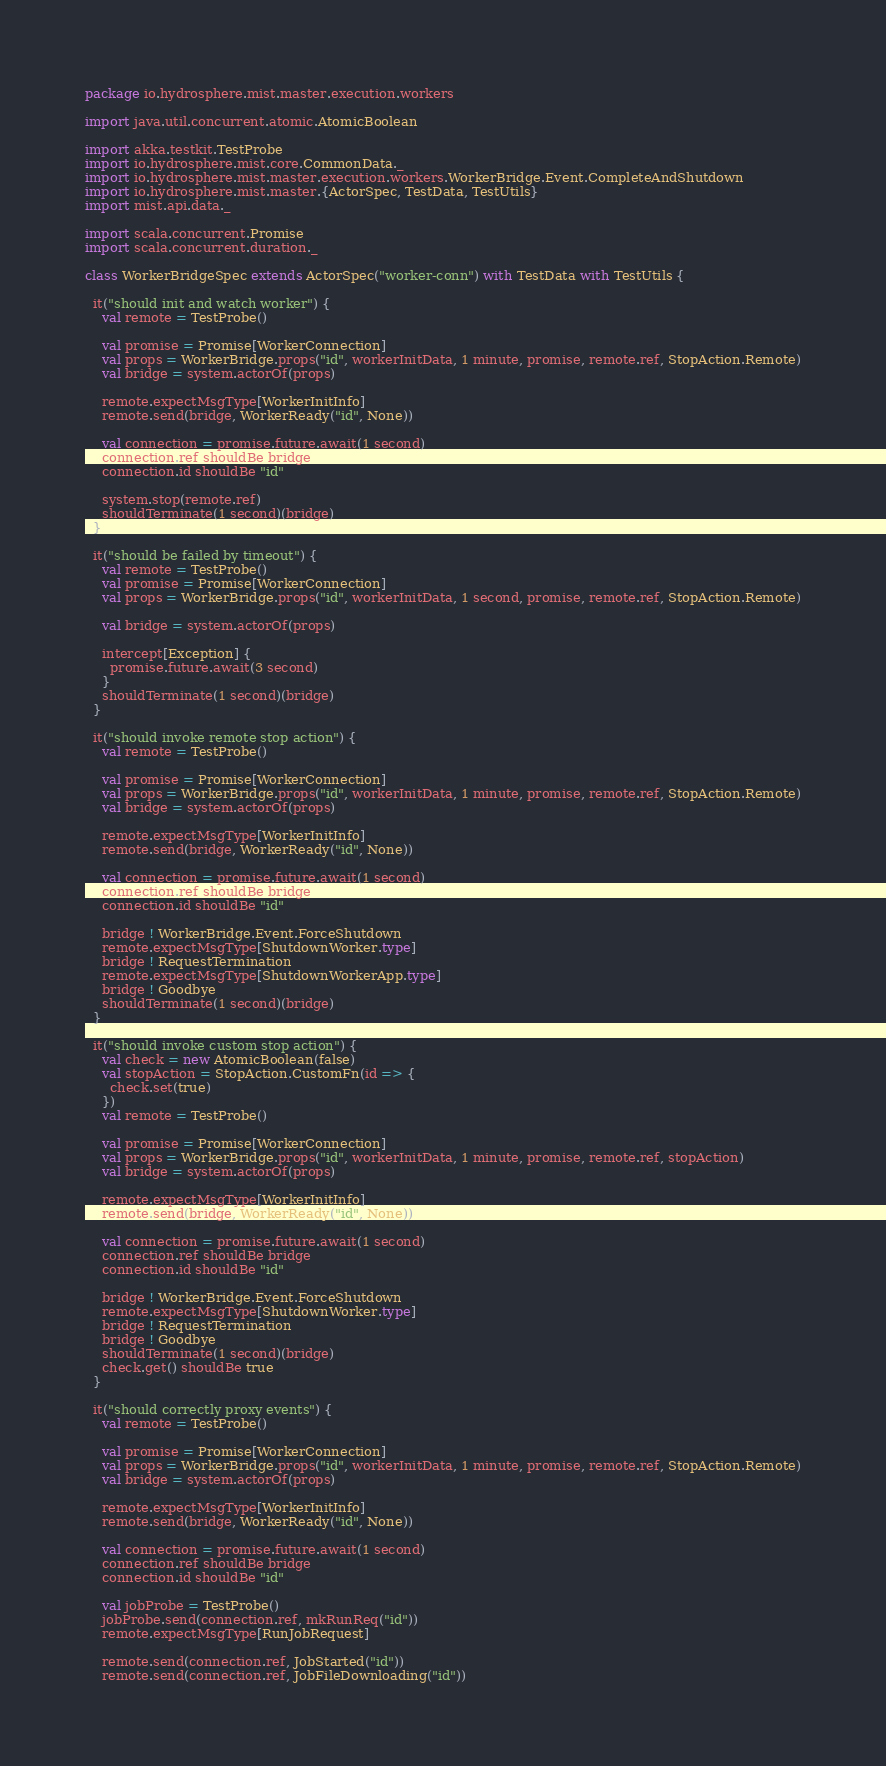<code> <loc_0><loc_0><loc_500><loc_500><_Scala_>package io.hydrosphere.mist.master.execution.workers

import java.util.concurrent.atomic.AtomicBoolean

import akka.testkit.TestProbe
import io.hydrosphere.mist.core.CommonData._
import io.hydrosphere.mist.master.execution.workers.WorkerBridge.Event.CompleteAndShutdown
import io.hydrosphere.mist.master.{ActorSpec, TestData, TestUtils}
import mist.api.data._

import scala.concurrent.Promise
import scala.concurrent.duration._

class WorkerBridgeSpec extends ActorSpec("worker-conn") with TestData with TestUtils {

  it("should init and watch worker") {
    val remote = TestProbe()

    val promise = Promise[WorkerConnection]
    val props = WorkerBridge.props("id", workerInitData, 1 minute, promise, remote.ref, StopAction.Remote)
    val bridge = system.actorOf(props)

    remote.expectMsgType[WorkerInitInfo]
    remote.send(bridge, WorkerReady("id", None))

    val connection = promise.future.await(1 second)
    connection.ref shouldBe bridge
    connection.id shouldBe "id"

    system.stop(remote.ref)
    shouldTerminate(1 second)(bridge)
  }

  it("should be failed by timeout") {
    val remote = TestProbe()
    val promise = Promise[WorkerConnection]
    val props = WorkerBridge.props("id", workerInitData, 1 second, promise, remote.ref, StopAction.Remote)

    val bridge = system.actorOf(props)

    intercept[Exception] {
      promise.future.await(3 second)
    }
    shouldTerminate(1 second)(bridge)
  }

  it("should invoke remote stop action") {
    val remote = TestProbe()

    val promise = Promise[WorkerConnection]
    val props = WorkerBridge.props("id", workerInitData, 1 minute, promise, remote.ref, StopAction.Remote)
    val bridge = system.actorOf(props)

    remote.expectMsgType[WorkerInitInfo]
    remote.send(bridge, WorkerReady("id", None))

    val connection = promise.future.await(1 second)
    connection.ref shouldBe bridge
    connection.id shouldBe "id"

    bridge ! WorkerBridge.Event.ForceShutdown
    remote.expectMsgType[ShutdownWorker.type]
    bridge ! RequestTermination
    remote.expectMsgType[ShutdownWorkerApp.type]
    bridge ! Goodbye
    shouldTerminate(1 second)(bridge)
  }

  it("should invoke custom stop action") {
    val check = new AtomicBoolean(false)
    val stopAction = StopAction.CustomFn(id => {
      check.set(true)
    })
    val remote = TestProbe()

    val promise = Promise[WorkerConnection]
    val props = WorkerBridge.props("id", workerInitData, 1 minute, promise, remote.ref, stopAction)
    val bridge = system.actorOf(props)

    remote.expectMsgType[WorkerInitInfo]
    remote.send(bridge, WorkerReady("id", None))

    val connection = promise.future.await(1 second)
    connection.ref shouldBe bridge
    connection.id shouldBe "id"

    bridge ! WorkerBridge.Event.ForceShutdown
    remote.expectMsgType[ShutdownWorker.type]
    bridge ! RequestTermination
    bridge ! Goodbye
    shouldTerminate(1 second)(bridge)
    check.get() shouldBe true
  }

  it("should correctly proxy events") {
    val remote = TestProbe()

    val promise = Promise[WorkerConnection]
    val props = WorkerBridge.props("id", workerInitData, 1 minute, promise, remote.ref, StopAction.Remote)
    val bridge = system.actorOf(props)

    remote.expectMsgType[WorkerInitInfo]
    remote.send(bridge, WorkerReady("id", None))

    val connection = promise.future.await(1 second)
    connection.ref shouldBe bridge
    connection.id shouldBe "id"

    val jobProbe = TestProbe()
    jobProbe.send(connection.ref, mkRunReq("id"))
    remote.expectMsgType[RunJobRequest]

    remote.send(connection.ref, JobStarted("id"))
    remote.send(connection.ref, JobFileDownloading("id"))</code> 